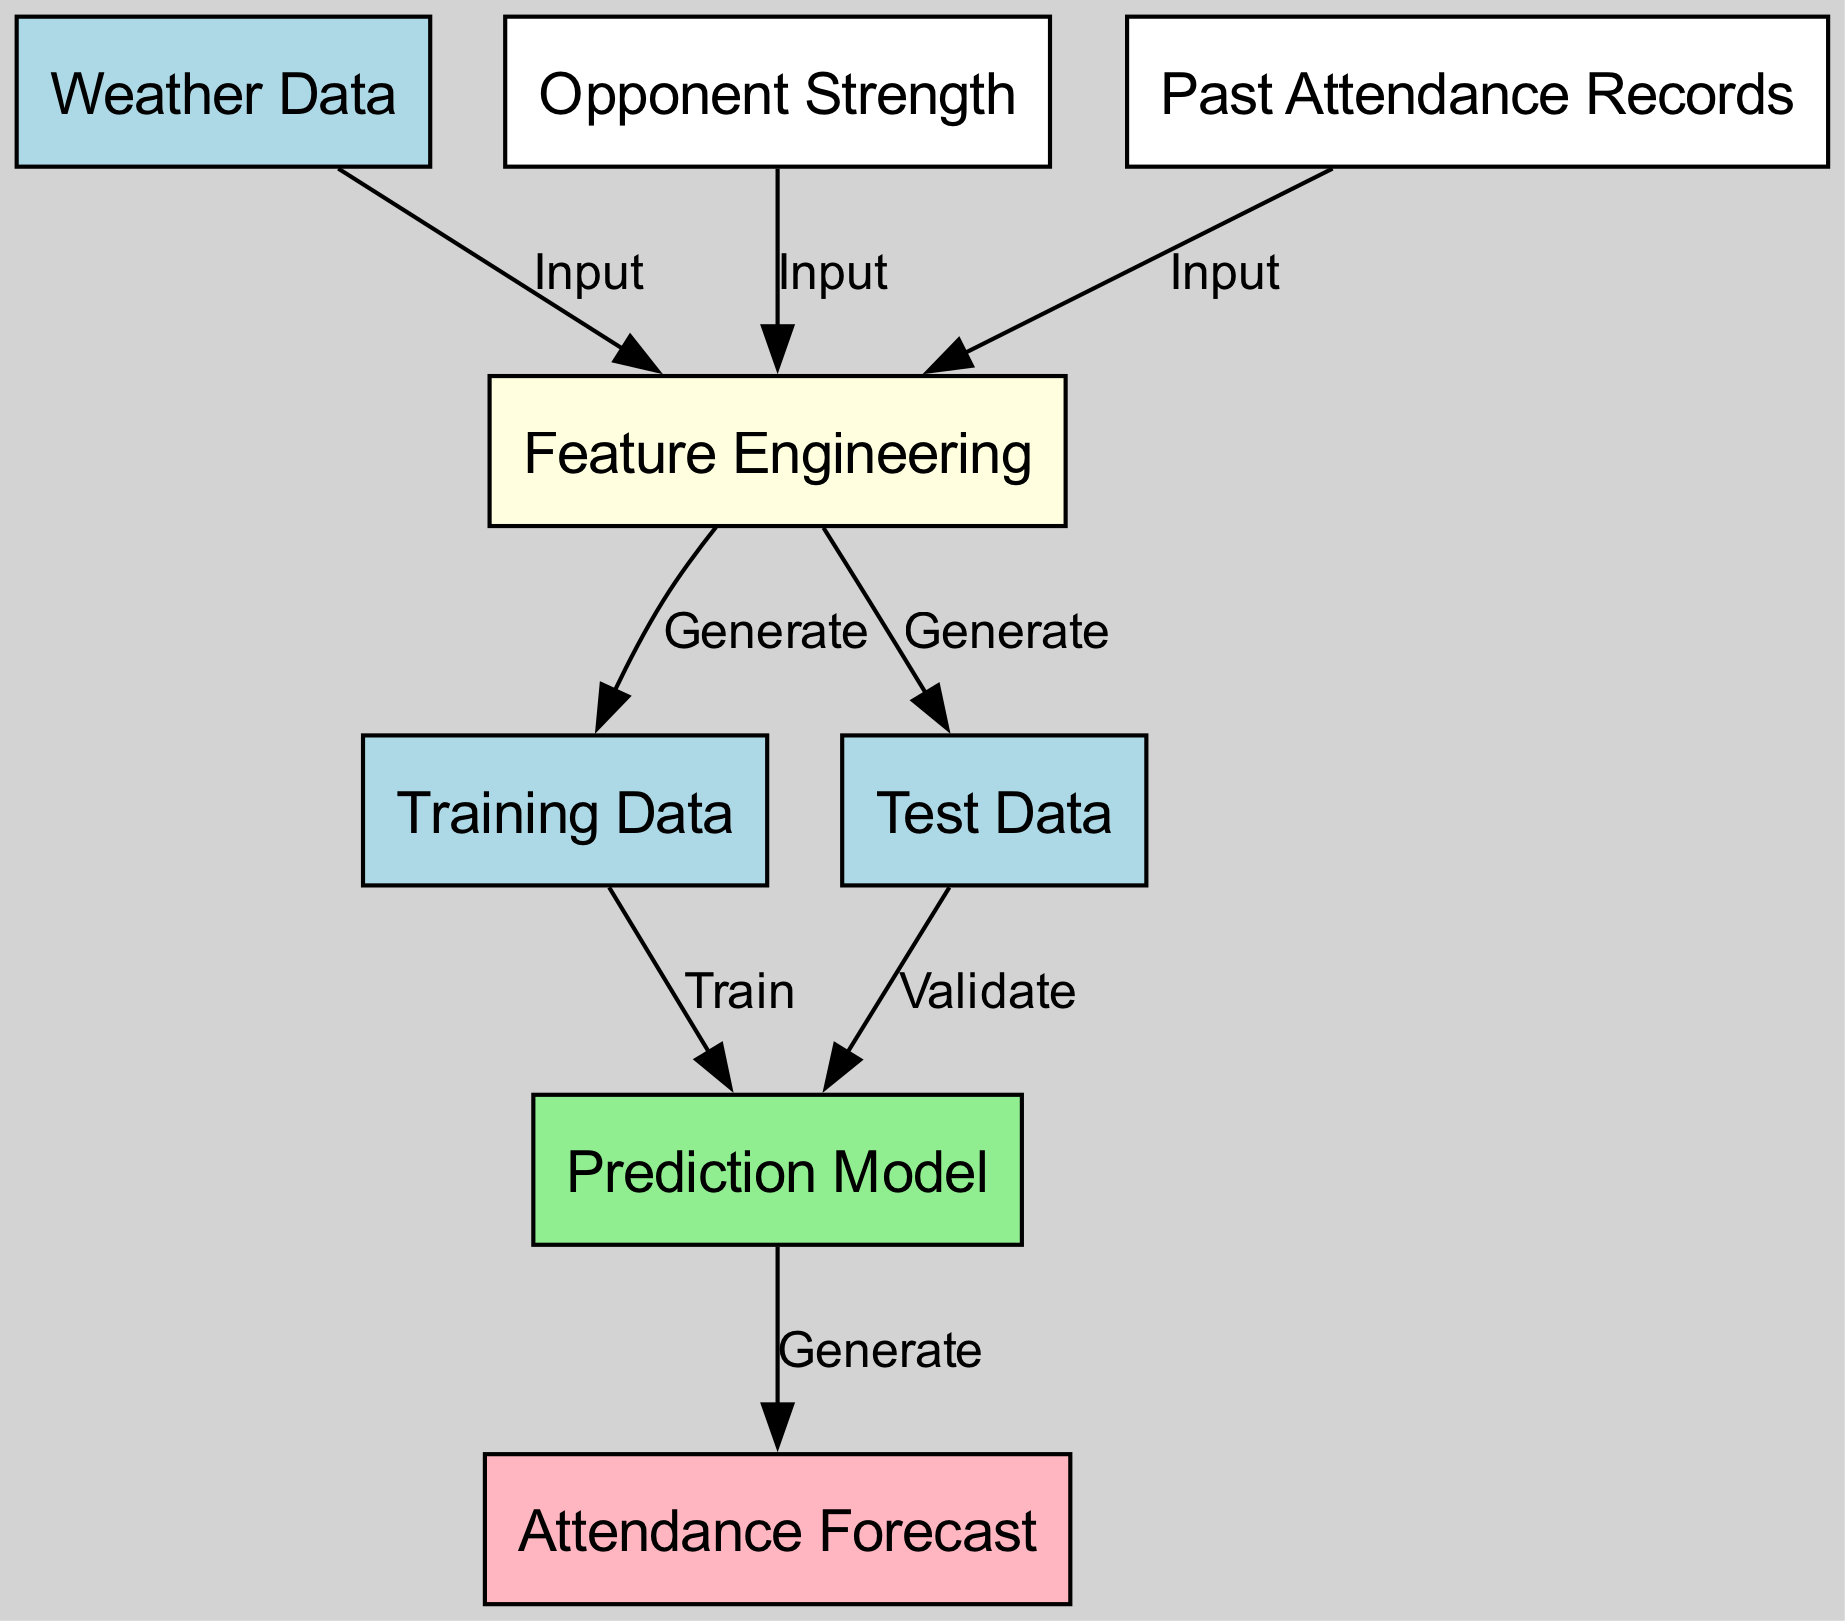What are the inputs to Feature Engineering? The inputs to Feature Engineering are Weather Data, Opponent Strength, and Past Attendance Records, as indicated by the edges connecting these nodes to Feature Engineering.
Answer: Weather Data, Opponent Strength, Past Attendance Records How many nodes are in the diagram? The diagram contains eight nodes: Weather Data, Opponent Strength, Past Attendance Records, Feature Engineering, Training Data, Test Data, Prediction Model, and Attendance Forecast. This is determined by counting each unique node listed in the diagram.
Answer: 8 What node follows Training Data in the diagram? The node that follows Training Data is Prediction Model, connected by the "Train" edge. This indicates that the Prediction Model is trained using the generated Training Data.
Answer: Prediction Model Which node is responsible for generating the Attendance Forecast? The node responsible for generating the Attendance Forecast is Prediction Model, which connects to Attendance Forecast with a "Generate" label, indicating its role in producing the forecast.
Answer: Prediction Model How many edges connect to Feature Engineering? There are three edges connecting to Feature Engineering: one from Weather Data, one from Opponent Strength, and one from Past Attendance Records. These edges indicate that Feature Engineering receives inputs from these three nodes.
Answer: 3 What is the relationship between Test Data and Prediction Model? The relationship between Test Data and Prediction Model is that Test Data is used to validate the Prediction Model, as indicated by the "Validate" label on the connecting edge.
Answer: Validate Which node acts as the starting point for gathering information? The starting points for gathering information are Weather Data, Opponent Strength, and Past Attendance Records, which are all inputs to Feature Engineering.
Answer: Weather Data, Opponent Strength, Past Attendance Records What type of data does Feature Engineering generate? Feature Engineering generates both Training Data and Test Data as outputs that are necessary for training and validating the Prediction Model.
Answer: Training Data, Test Data What output is generated by Prediction Model? The output generated by the Prediction Model is the Attendance Forecast, which is the final goal of the diagram, indicating the attendance prediction process.
Answer: Attendance Forecast 